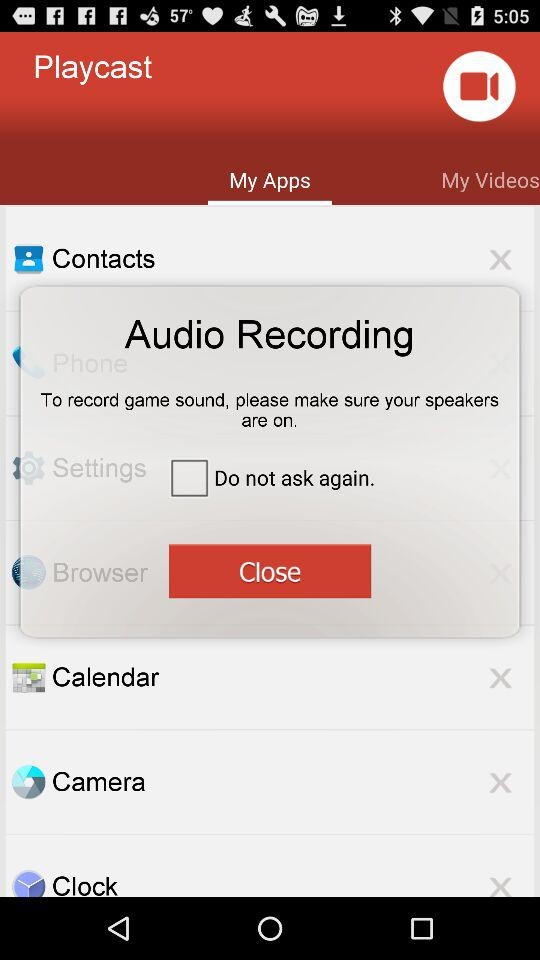What's the status of "Do not ask again."? The status is "off". 